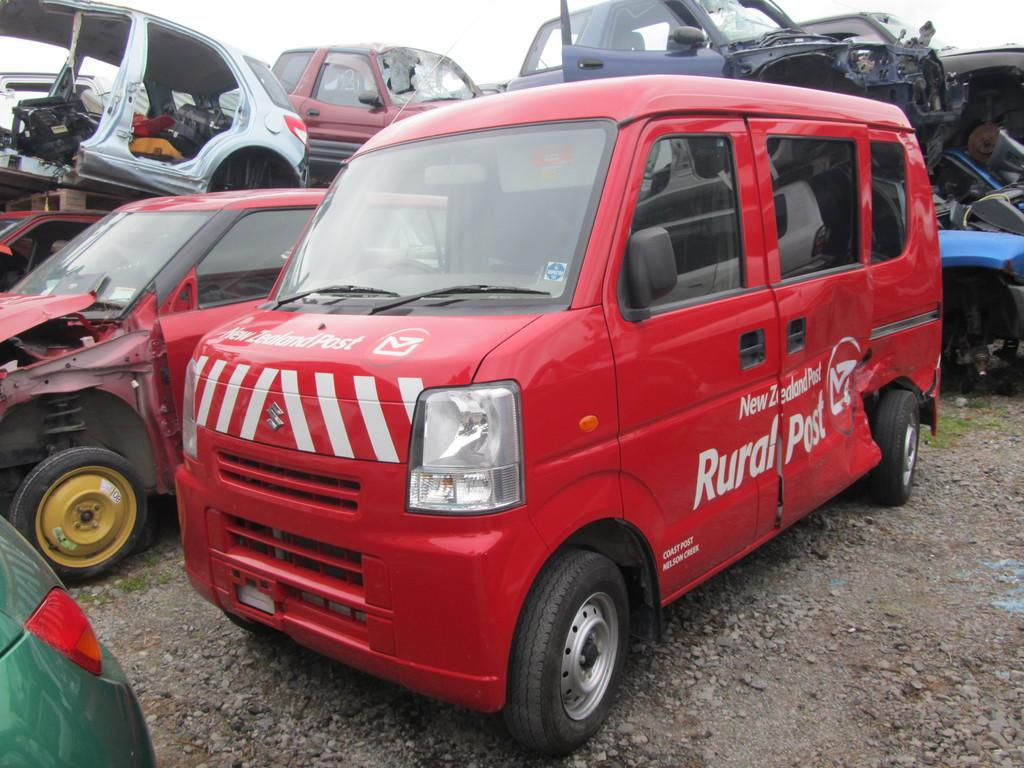Where was the image taken? The image was taken outside. What can be seen in the image besides the outdoor setting? There are multiple cars in the image. What is the condition of the cars in the image? The cars are damaged. What can be said about the appearance of the cars in terms of color? The cars are of different colors. What type of bird can be seen sitting on the middle car in the image? There is no bird, specifically a robin, present in the image. 